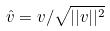<formula> <loc_0><loc_0><loc_500><loc_500>\hat { v } = v / \sqrt { | | v | | ^ { 2 } }</formula> 